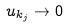<formula> <loc_0><loc_0><loc_500><loc_500>u _ { k _ { j } } \rightarrow 0</formula> 